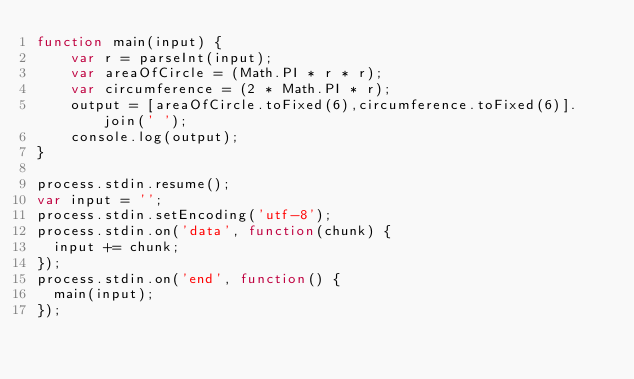<code> <loc_0><loc_0><loc_500><loc_500><_JavaScript_>function main(input) {
    var r = parseInt(input);
    var areaOfCircle = (Math.PI * r * r);
    var circumference = (2 * Math.PI * r);
    output = [areaOfCircle.toFixed(6),circumference.toFixed(6)].join(' ');
    console.log(output);
}

process.stdin.resume();
var input = '';  
process.stdin.setEncoding('utf-8');
process.stdin.on('data', function(chunk) {
  input += chunk;
});
process.stdin.on('end', function() {
  main(input);
});</code> 